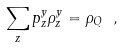Convert formula to latex. <formula><loc_0><loc_0><loc_500><loc_500>\sum _ { z } p ^ { y } _ { z } \rho ^ { y } _ { z } = \rho _ { Q } \ ,</formula> 